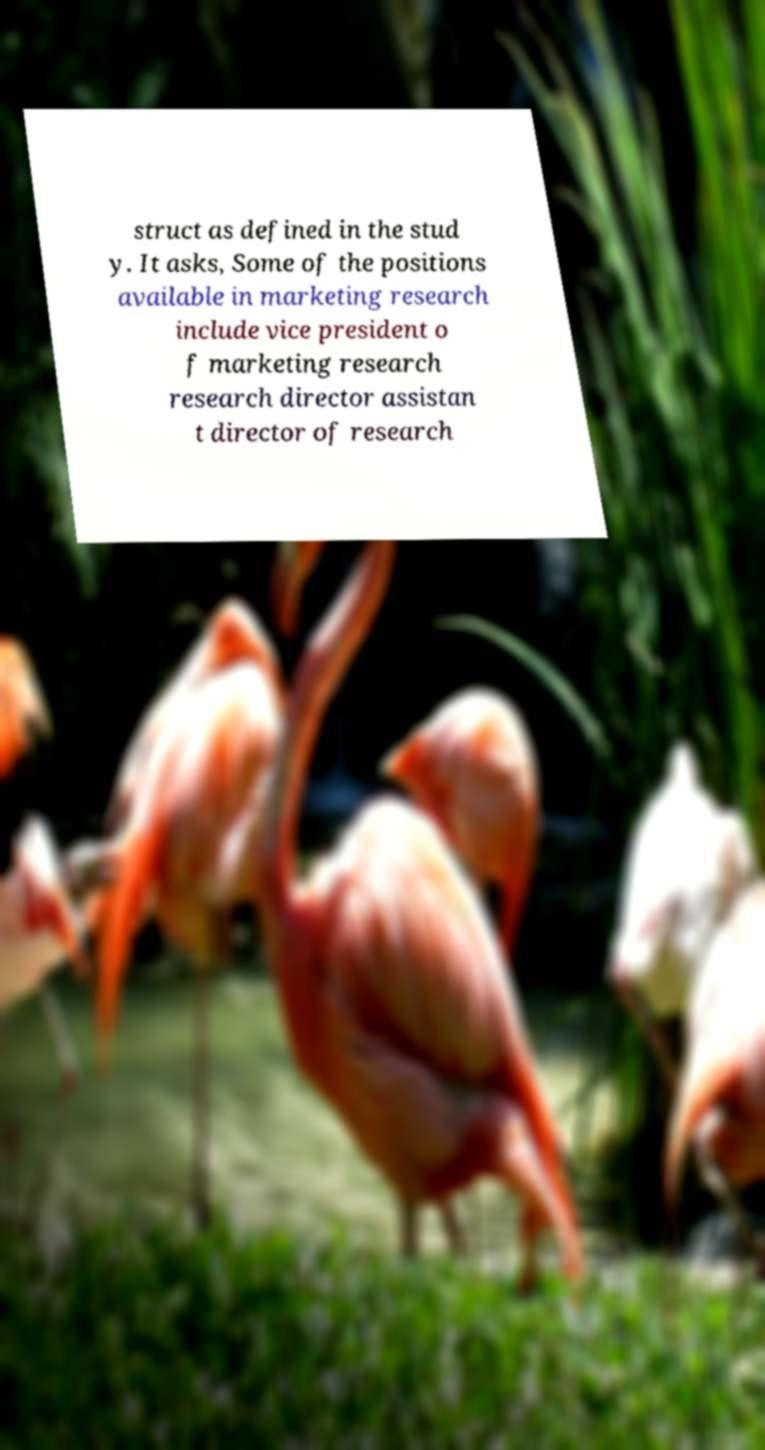Can you accurately transcribe the text from the provided image for me? struct as defined in the stud y. It asks, Some of the positions available in marketing research include vice president o f marketing research research director assistan t director of research 